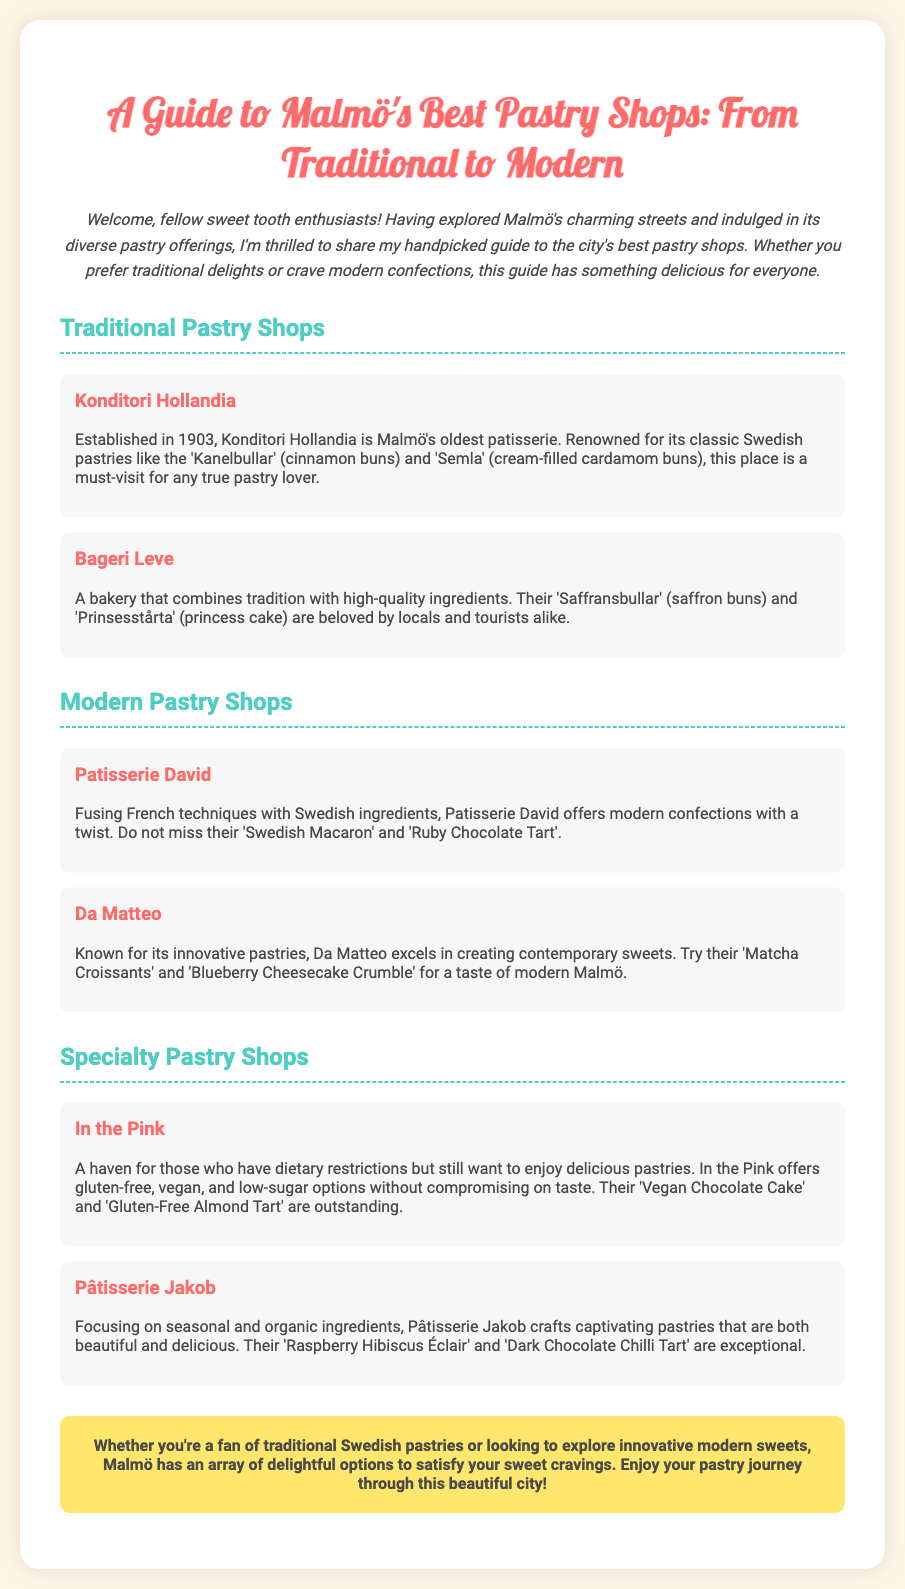What is the title of the guide? The title is explicitly stated at the top of the document.
Answer: A Guide to Malmö's Best Pastry Shops: From Traditional to Modern When was Konditori Hollandia established? The establishment year for Konditori Hollandia is mentioned in the text.
Answer: 1903 Which pastry is known as 'Semla'? The document describes various traditional pastries, and 'Semla' is noted as a specific type.
Answer: Cream-filled cardamom buns Which pastry shop features Vegan options? The document states that certain pastry shops offer special dietary options, and identifies one of them.
Answer: In the Pink What type of cake does Pâtisserie Jakob offer? The document provides specific examples of pastries offered at Pâtisserie Jakob, implying their focus.
Answer: Raspberry Hibiscus Éclair How many traditional pastry shops are listed in the document? Counting the number of shops in the 'Traditional Pastry Shops' section yields this total.
Answer: Two What is a unique item from Patisserie David? The document lists specific pastries from Patisserie David, highlighting one of its notable offerings.
Answer: Swedish Macaron What is the primary theme of the flyer? The overall focus of the document can be inferred from the introduction and title.
Answer: Best Pastry Shops in Malmö 